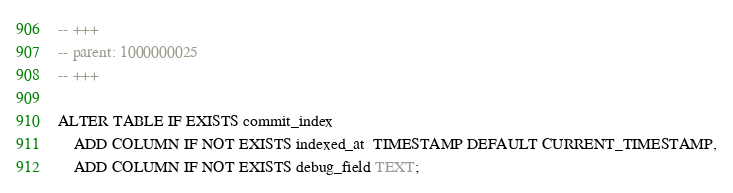<code> <loc_0><loc_0><loc_500><loc_500><_SQL_>-- +++
-- parent: 1000000025
-- +++

ALTER TABLE IF EXISTS commit_index
    ADD COLUMN IF NOT EXISTS indexed_at  TIMESTAMP DEFAULT CURRENT_TIMESTAMP,
    ADD COLUMN IF NOT EXISTS debug_field TEXT;
</code> 